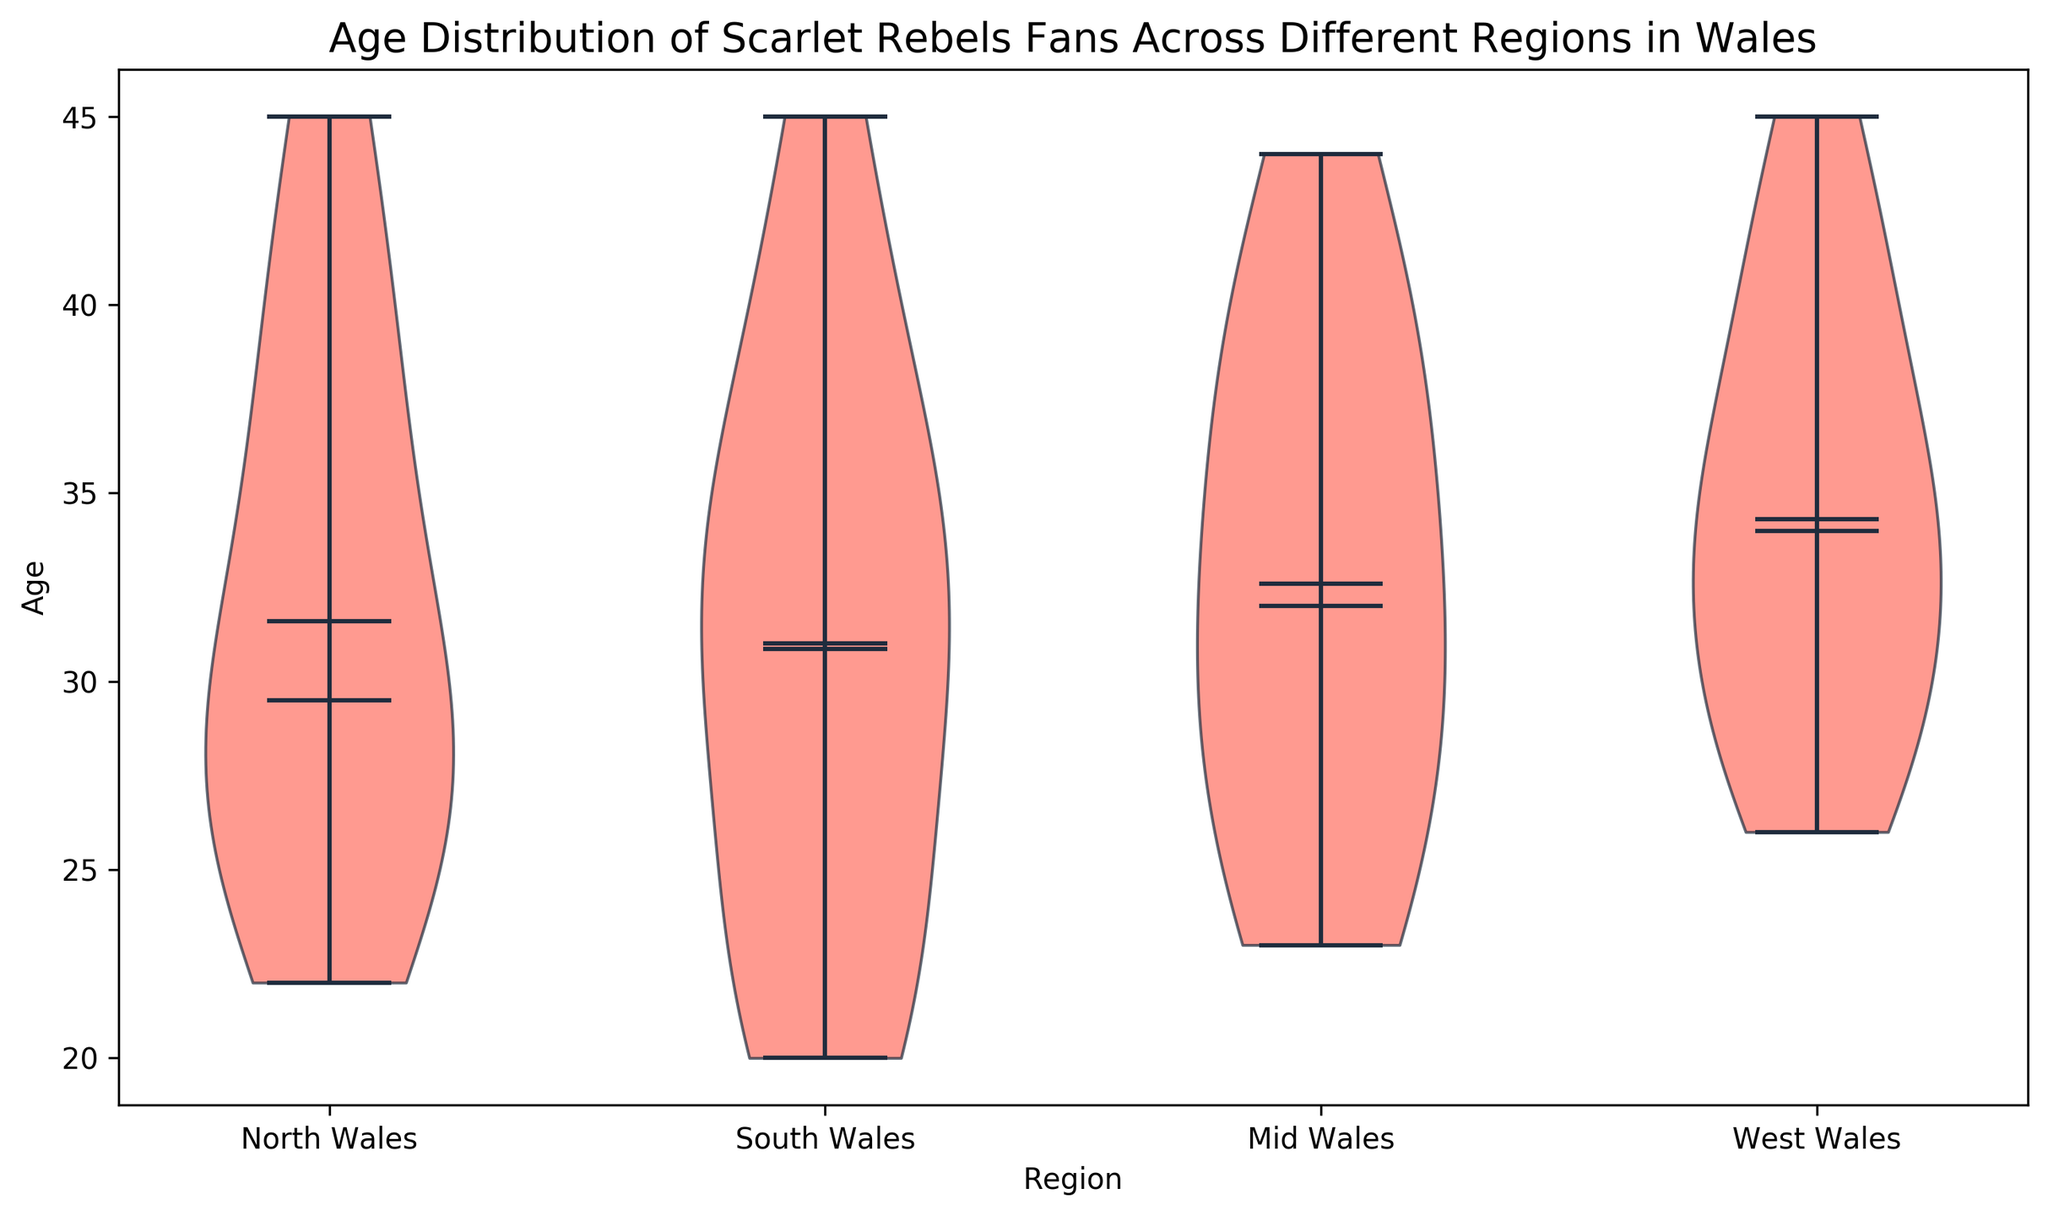Do the fans in South Wales tend to be younger or older compared to fans in Mid Wales? To determine this, compare the overall shape and spread of the age distributions (the widths of the violins) for South Wales and Mid Wales. The violin plots for South Wales tend to show a younger distribution, as it has denser sections at lower age ranges compared to Mid Wales, which peaks more towards mid to upper age ranges.
Answer: South Wales tends to have younger fans What is the median age of fans in North Wales? The median age is shown by the line inside the violin plot. For North Wales, look for the dashed line inside the North Wales violin plot. The median age appears to be around 30 years old.
Answer: 30 years old Which region has the highest variability in age among its fans? The variability can be assessed by comparing the overall spread (height) of the violin plots. West Wales displays the widest range from min to max ages (extreme ends of the violins), indicating higher variability.
Answer: West Wales What is the average age difference between fans in South Wales and fans in North Wales? From the plot, estimate the mean lines within the violins. South Wales has a mean around 30 years, and North Wales is slightly higher at around 33 years. The average age difference is thus 33 - 30 = 3 years.
Answer: 3 years Is the age distribution of fans in Mid Wales more symmetric compared to the other regions? Symmetry in the violin plot is indicated by the shape. Mid Wales has a more symmetric distribution, as it has a relatively even spread on both sides of the median line compared to, for example, the more skewed distribution in West Wales.
Answer: Yes Which region has the oldest median age among the Scarlet Rebels fans? Check the median lines (dashed lines) within each violin plot. West Wales shows the highest median age.
Answer: West Wales Is there any region where fans' age goes beyond the age of 45? Look for any violin plots whose range exceeds 45 on the y-axis. None of the violin plots extend beyond 45.
Answer: No Do more fans in North Wales fall within the age range of 30 to 40 compared to South Wales? Compare the densities (widths) of the violins within the 30-40 age range. North Wales has more density (wider plot) compared to South Wales in this range, indicating more fans.
Answer: Yes Which region's fan base is centered around ages closer to the minimum age limit? The region whose violin plot has the most density (widest part) closest to the lower age limit (20) is South Wales.
Answer: South Wales Are fans from North Wales generally older than fans from West Wales? Compare the mean and median lines of North Wales and West Wales. North Wales shows a slightly lower mean and median, indicating its fans are generally younger.
Answer: No 